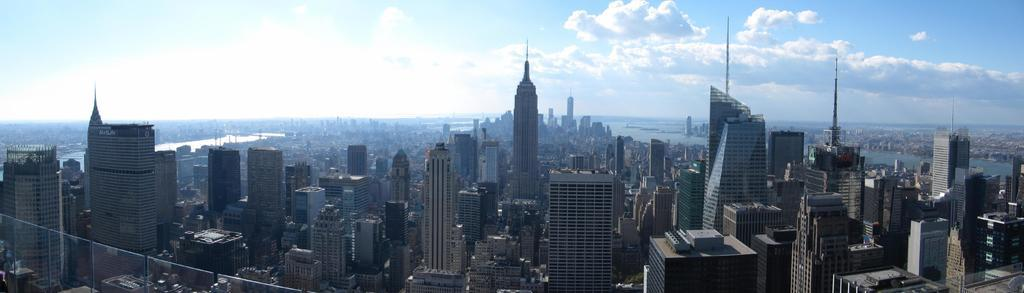What type of location is depicted in the image? The image shows a view of the city. What are some prominent features of the cityscape? There are skyscrapers and other buildings in the image. Is there any indication of a natural feature in the image? There might be a river in the image. What can be seen in the sky in the image? Clouds are visible in the sky. What type of hose is being used to water the plants in the image? There is no hose or plants present in the image; it shows a view of the city with skyscrapers, buildings, and clouds. What is the cause of death for the person in the image? There is no person or indication of death in the image; it shows a view of the city with skyscrapers, buildings, and clouds. 